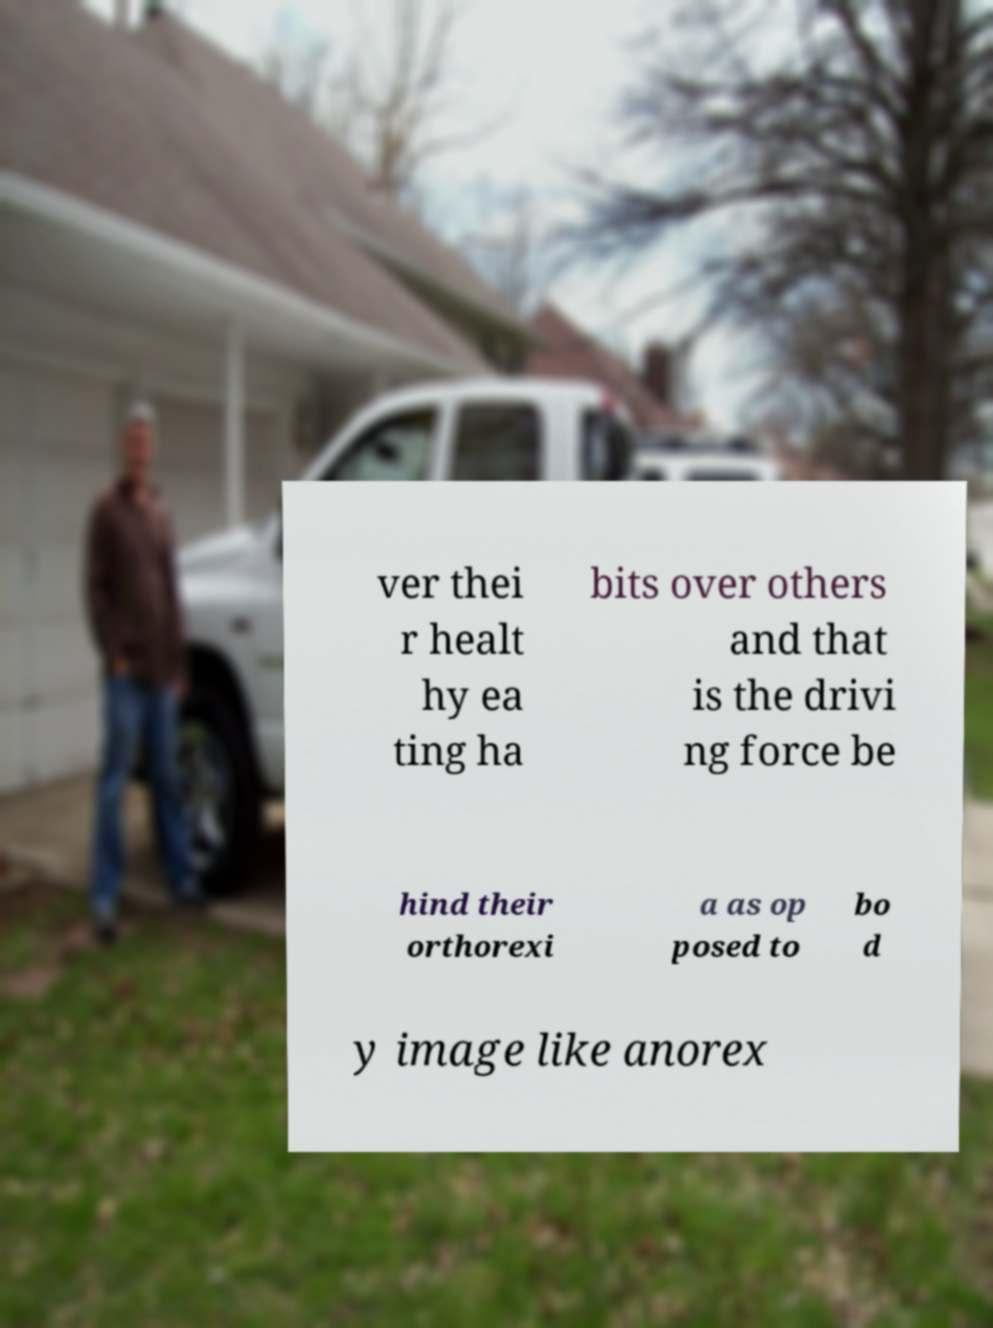There's text embedded in this image that I need extracted. Can you transcribe it verbatim? ver thei r healt hy ea ting ha bits over others and that is the drivi ng force be hind their orthorexi a as op posed to bo d y image like anorex 